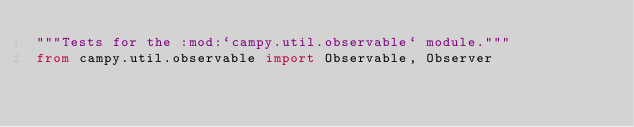Convert code to text. <code><loc_0><loc_0><loc_500><loc_500><_Python_>"""Tests for the :mod:`campy.util.observable` module."""
from campy.util.observable import Observable, Observer
</code> 